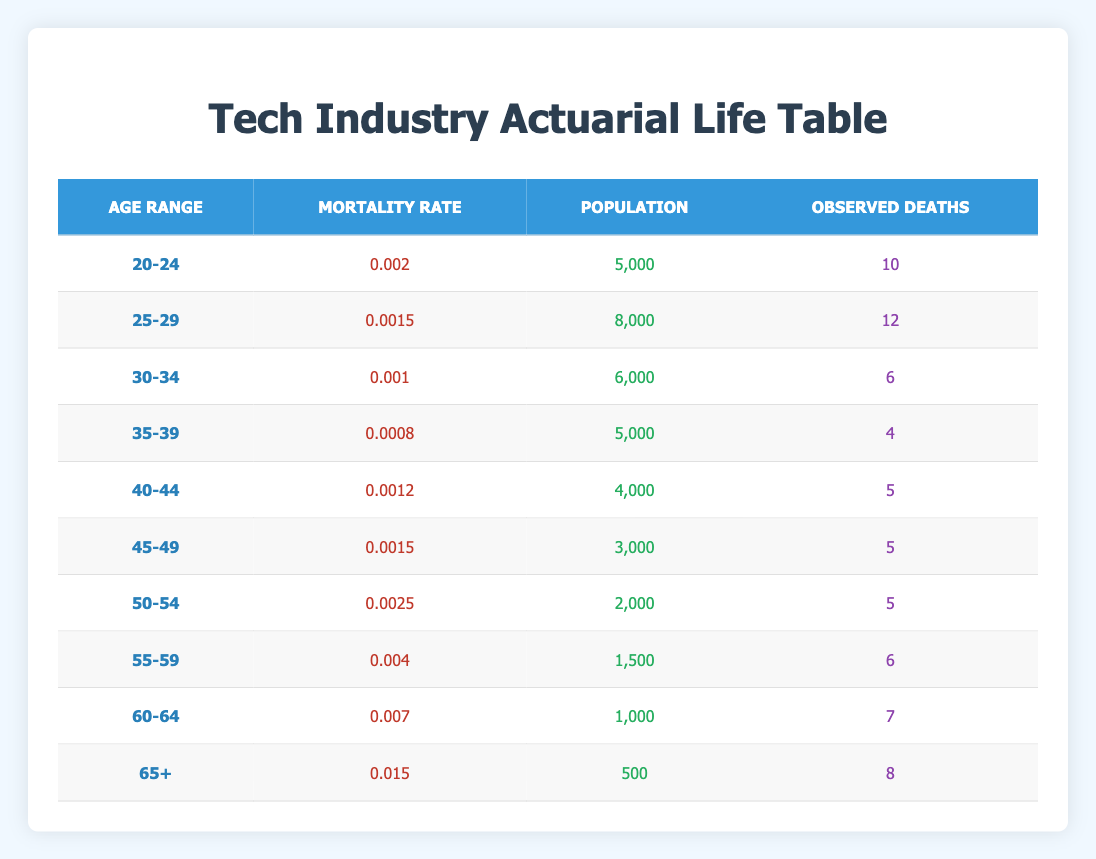What is the mortality rate for the age group 50-54? The table shows that the mortality rate for the age group 50-54 is listed directly under the "Mortality Rate" column corresponding to that age range. It is 0.0025.
Answer: 0.0025 How many observed deaths were reported for the age group 30-34? By looking at the "Observed Deaths" column for the age group 30-34, it states that there were 6 observed deaths.
Answer: 6 Which age group has the highest mortality rate? To find the highest mortality rate, compare the values in the "Mortality Rate" column for all age groups. The age group 65+ has the highest value at 0.015.
Answer: 65+ What is the total population of all age groups combined? Add the populations from each age group: 5000 + 8000 + 6000 + 5000 + 4000 + 3000 + 2000 + 1500 + 1000 + 500 = 25,000.
Answer: 25000 Are there more observed deaths in the age group 60-64 than in the age group 55-59? Compare the "Observed Deaths" for both age groups. The age group 55-59 has 6 observed deaths, while the age group 60-64 has 7. Since 7 is greater than 6, the statement is true.
Answer: Yes What is the average mortality rate across all age groups? First, sum each mortality rate: 0.002 + 0.0015 + 0.001 + 0.0008 + 0.0012 + 0.0015 + 0.0025 + 0.004 + 0.007 + 0.015 = 0.0365. Then, divide by the number of age groups, which is 10: 0.0365 / 10 = 0.00365.
Answer: 0.00365 How many age groups reported less than 5 observed deaths? Look at the "Observed Deaths" column and count the age groups with a value less than 5. The age groups 20-24, 35-39, 40-44, and 45-49 each reported less than 5 deaths. That is four age groups.
Answer: 4 Is the mortality rate for the age group 45-49 higher than that for the age group 40-44? Find the mortality rates for both groups: 45-49 has 0.0015, while 40-44 has 0.0012. Since 0.0015 is greater than 0.0012, the statement is true.
Answer: Yes 